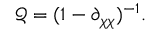<formula> <loc_0><loc_0><loc_500><loc_500>\ m a t h s c r { Q } = ( 1 - \partial _ { \chi \chi } ) ^ { - 1 } .</formula> 